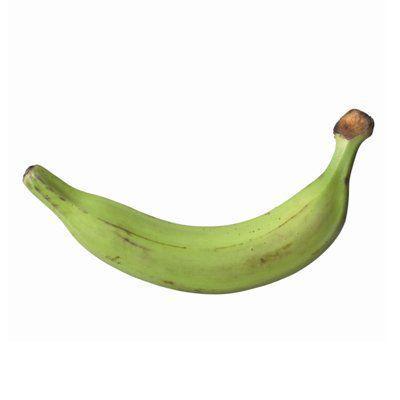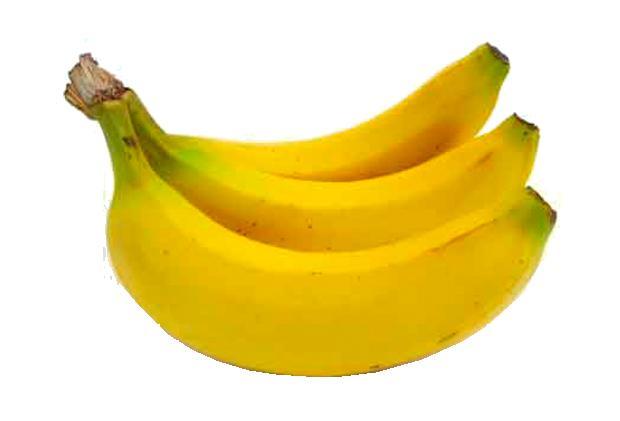The first image is the image on the left, the second image is the image on the right. For the images displayed, is the sentence "The left image has at least one banana with it's end facing left, and the right image has a bunch of bananas with it's end facing right." factually correct? Answer yes or no. Yes. The first image is the image on the left, the second image is the image on the right. Analyze the images presented: Is the assertion "The ends of the bananas in both pictures are pointing in opposite directions." valid? Answer yes or no. Yes. 